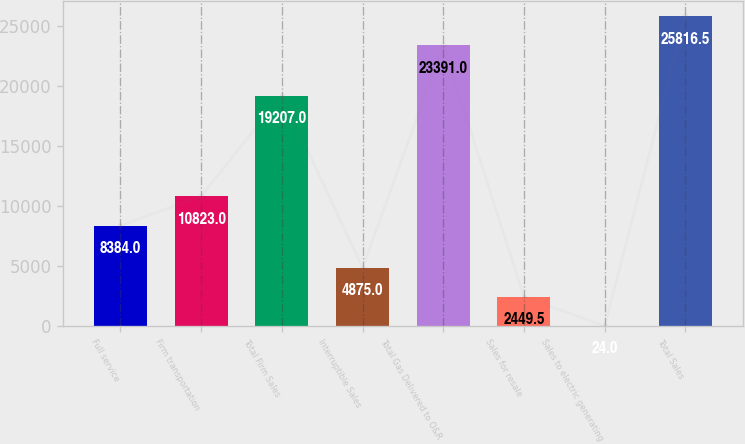Convert chart. <chart><loc_0><loc_0><loc_500><loc_500><bar_chart><fcel>Full service<fcel>Firm transportation<fcel>Total Firm Sales<fcel>Interruptible Sales<fcel>Total Gas Delivered to O&R<fcel>Sales for resale<fcel>Sales to electric generating<fcel>Total Sales<nl><fcel>8384<fcel>10823<fcel>19207<fcel>4875<fcel>23391<fcel>2449.5<fcel>24<fcel>25816.5<nl></chart> 